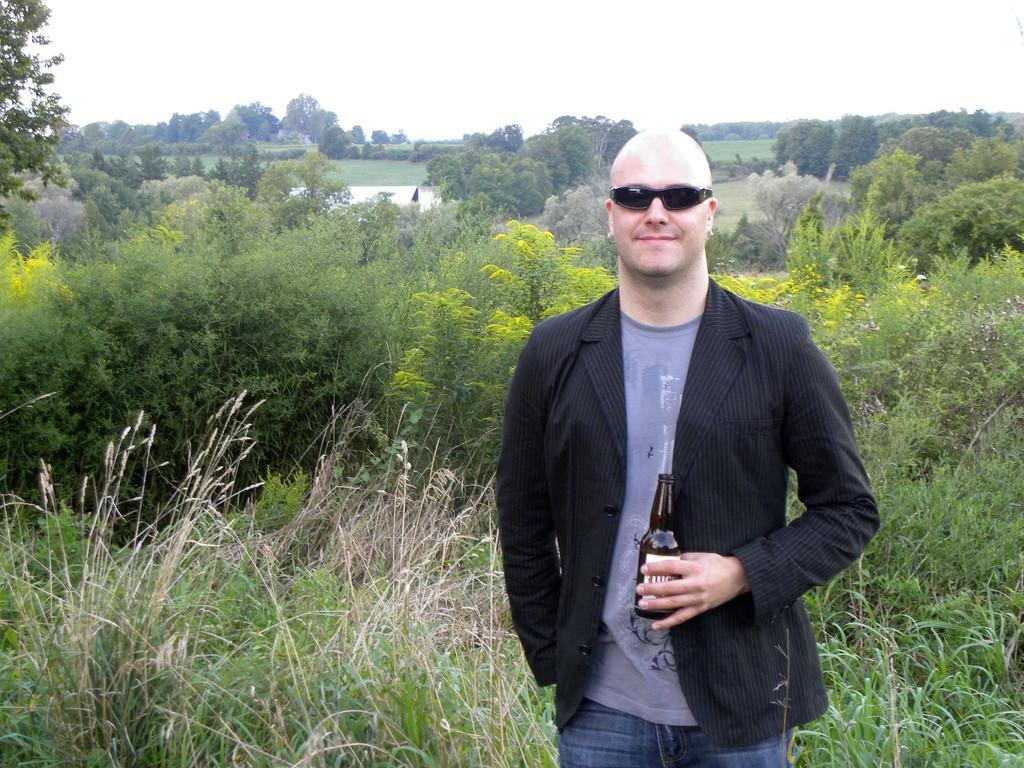Could you give a brief overview of what you see in this image? A man is standing wearing a blazer and holding a glass bottle. There are trees and there is water at the back. There is sky at the top. 